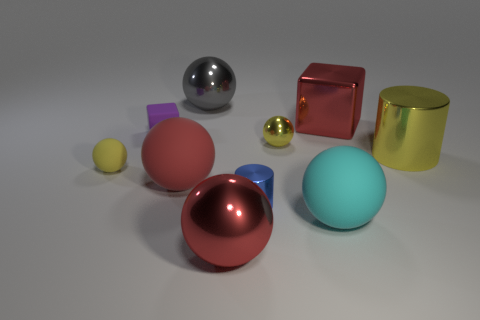Subtract all purple cubes. How many yellow balls are left? 2 Subtract all yellow metal spheres. How many spheres are left? 5 Subtract all cyan spheres. How many spheres are left? 5 Subtract 3 balls. How many balls are left? 3 Subtract all green balls. Subtract all green blocks. How many balls are left? 6 Subtract all spheres. How many objects are left? 4 Subtract all big cyan balls. Subtract all yellow rubber balls. How many objects are left? 8 Add 7 big cylinders. How many big cylinders are left? 8 Add 4 green rubber cylinders. How many green rubber cylinders exist? 4 Subtract 0 brown blocks. How many objects are left? 10 